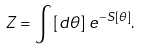<formula> <loc_0><loc_0><loc_500><loc_500>Z = \int \left [ d \theta \right ] \, e ^ { - S [ \theta ] } .</formula> 